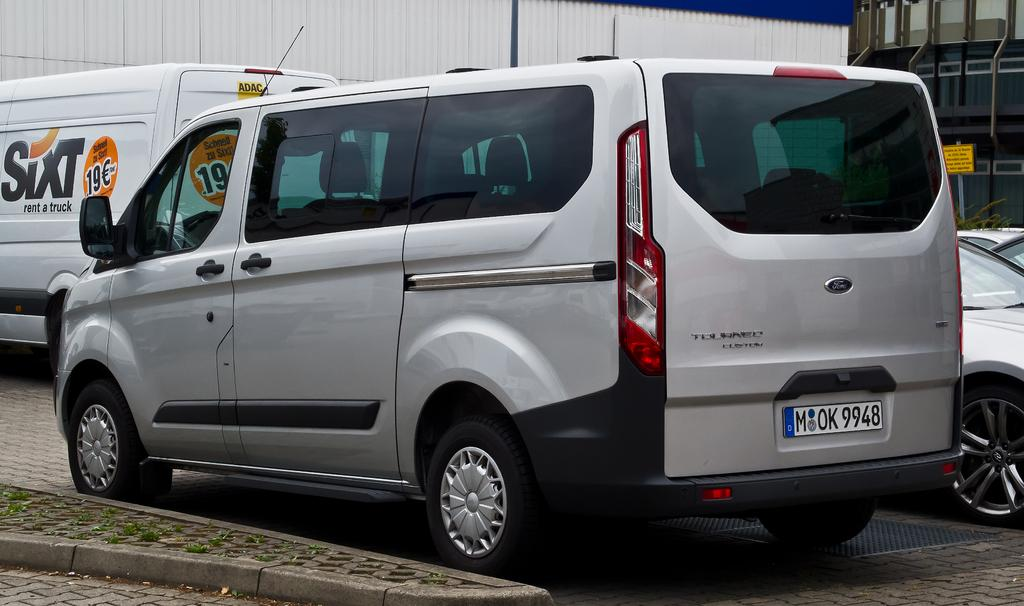Provide a one-sentence caption for the provided image. A gray van is parked at the curb behind a Sixt rental truck. 